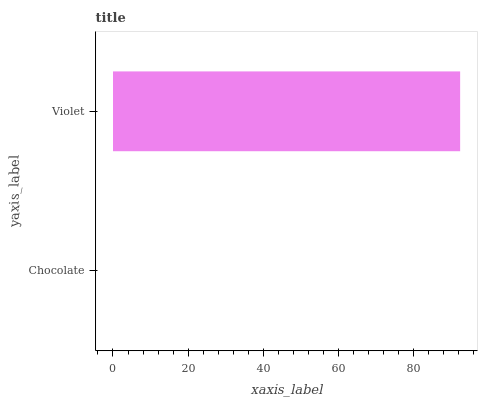Is Chocolate the minimum?
Answer yes or no. Yes. Is Violet the maximum?
Answer yes or no. Yes. Is Violet the minimum?
Answer yes or no. No. Is Violet greater than Chocolate?
Answer yes or no. Yes. Is Chocolate less than Violet?
Answer yes or no. Yes. Is Chocolate greater than Violet?
Answer yes or no. No. Is Violet less than Chocolate?
Answer yes or no. No. Is Violet the high median?
Answer yes or no. Yes. Is Chocolate the low median?
Answer yes or no. Yes. Is Chocolate the high median?
Answer yes or no. No. Is Violet the low median?
Answer yes or no. No. 